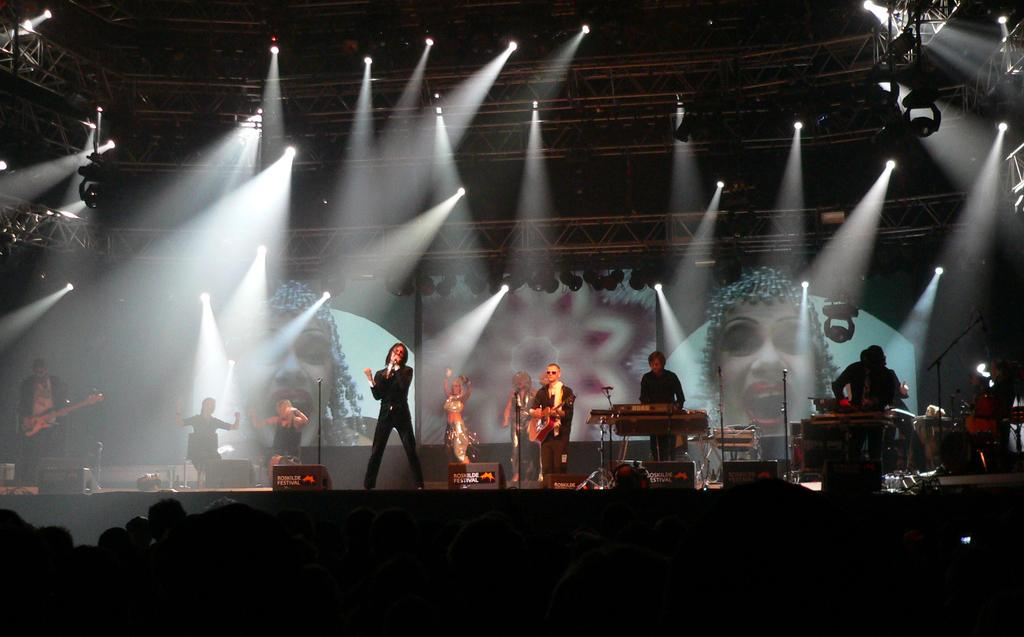What are the musicians in the image doing? There is a man playing guitar, a man playing piano, and a man singing through a microphone in the image. What can be seen in the background of the image? Show lights and a set are visible in the background of the image. What type of brass instrument is being played by the man in the image? There is no brass instrument being played in the image; the musicians are playing a guitar, piano, and singing through a microphone. 